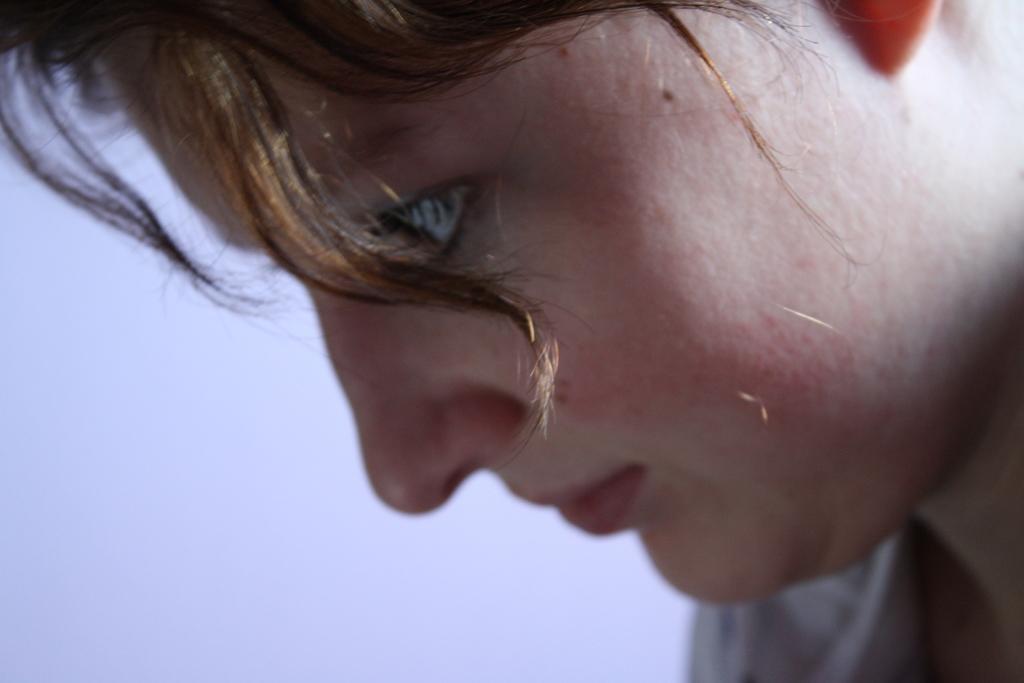Can you describe this image briefly? In this image a person is visible. There is hair on her face. The background is white. 